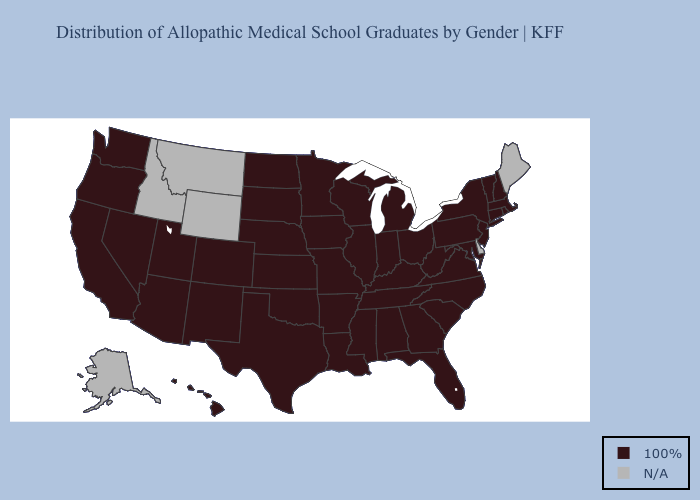Name the states that have a value in the range N/A?
Write a very short answer. Alaska, Delaware, Idaho, Maine, Montana, Wyoming. What is the lowest value in the West?
Short answer required. 100%. What is the value of Arizona?
Keep it brief. 100%. What is the value of Nevada?
Answer briefly. 100%. What is the highest value in the USA?
Short answer required. 100%. Name the states that have a value in the range 100%?
Concise answer only. Alabama, Arizona, Arkansas, California, Colorado, Connecticut, Florida, Georgia, Hawaii, Illinois, Indiana, Iowa, Kansas, Kentucky, Louisiana, Maryland, Massachusetts, Michigan, Minnesota, Mississippi, Missouri, Nebraska, Nevada, New Hampshire, New Jersey, New Mexico, New York, North Carolina, North Dakota, Ohio, Oklahoma, Oregon, Pennsylvania, Rhode Island, South Carolina, South Dakota, Tennessee, Texas, Utah, Vermont, Virginia, Washington, West Virginia, Wisconsin. What is the value of Hawaii?
Answer briefly. 100%. Name the states that have a value in the range N/A?
Quick response, please. Alaska, Delaware, Idaho, Maine, Montana, Wyoming. What is the highest value in the South ?
Give a very brief answer. 100%. What is the highest value in the MidWest ?
Give a very brief answer. 100%. Name the states that have a value in the range N/A?
Keep it brief. Alaska, Delaware, Idaho, Maine, Montana, Wyoming. What is the value of Maryland?
Give a very brief answer. 100%. 